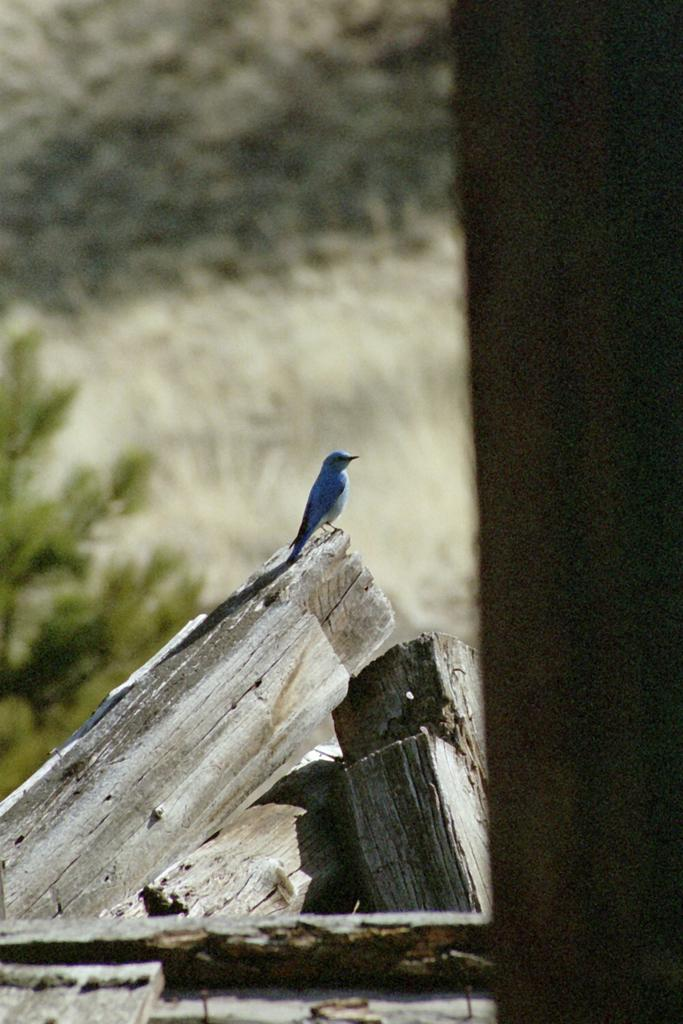What type of animal is in the image? There is a bird in the image. Where is the bird located? The bird is on wooden logs. Can you describe the background of the image? The background of the image is blurred. What type of vegetable is being consumed by the snails in the image? There are no snails or vegetables present in the image; it features a bird on wooden logs with a blurred background. 